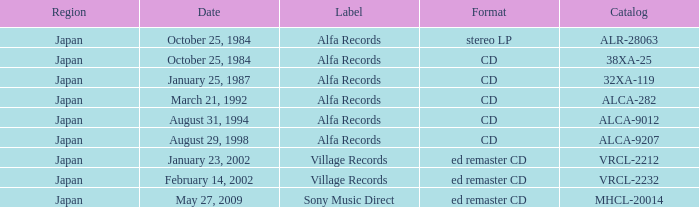What is the territory of the alfa records release with catalog alca-282? Japan. Would you be able to parse every entry in this table? {'header': ['Region', 'Date', 'Label', 'Format', 'Catalog'], 'rows': [['Japan', 'October 25, 1984', 'Alfa Records', 'stereo LP', 'ALR-28063'], ['Japan', 'October 25, 1984', 'Alfa Records', 'CD', '38XA-25'], ['Japan', 'January 25, 1987', 'Alfa Records', 'CD', '32XA-119'], ['Japan', 'March 21, 1992', 'Alfa Records', 'CD', 'ALCA-282'], ['Japan', 'August 31, 1994', 'Alfa Records', 'CD', 'ALCA-9012'], ['Japan', 'August 29, 1998', 'Alfa Records', 'CD', 'ALCA-9207'], ['Japan', 'January 23, 2002', 'Village Records', 'ed remaster CD', 'VRCL-2212'], ['Japan', 'February 14, 2002', 'Village Records', 'ed remaster CD', 'VRCL-2232'], ['Japan', 'May 27, 2009', 'Sony Music Direct', 'ed remaster CD', 'MHCL-20014']]} 